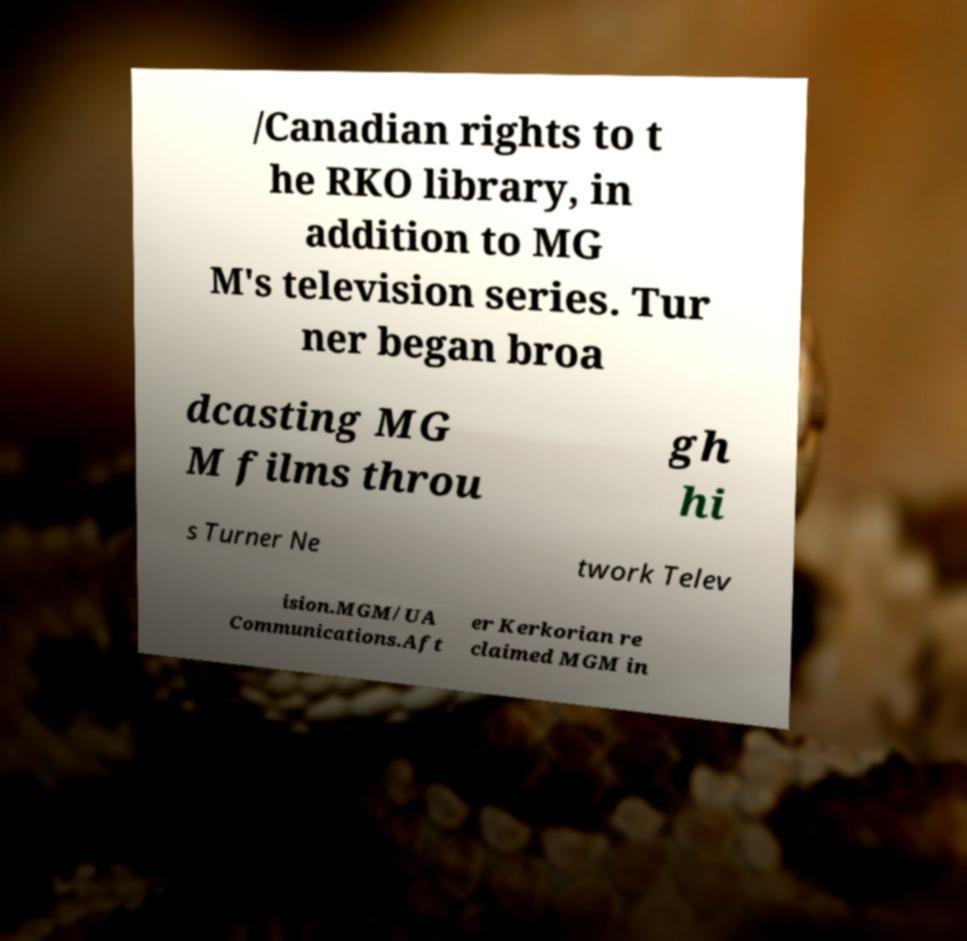Can you accurately transcribe the text from the provided image for me? /Canadian rights to t he RKO library, in addition to MG M's television series. Tur ner began broa dcasting MG M films throu gh hi s Turner Ne twork Telev ision.MGM/UA Communications.Aft er Kerkorian re claimed MGM in 